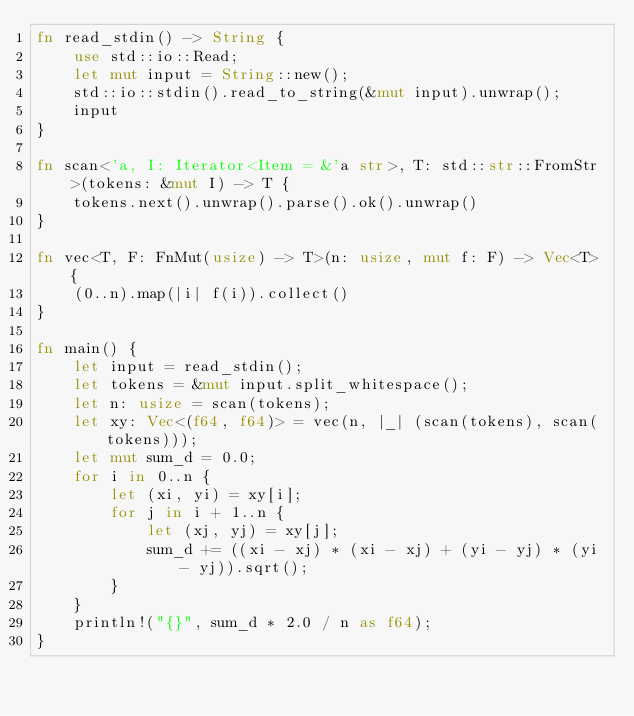Convert code to text. <code><loc_0><loc_0><loc_500><loc_500><_Rust_>fn read_stdin() -> String {
    use std::io::Read;
    let mut input = String::new();
    std::io::stdin().read_to_string(&mut input).unwrap();
    input
}

fn scan<'a, I: Iterator<Item = &'a str>, T: std::str::FromStr>(tokens: &mut I) -> T {
    tokens.next().unwrap().parse().ok().unwrap()
}

fn vec<T, F: FnMut(usize) -> T>(n: usize, mut f: F) -> Vec<T> {
    (0..n).map(|i| f(i)).collect()
}

fn main() {
    let input = read_stdin();
    let tokens = &mut input.split_whitespace();
    let n: usize = scan(tokens);
    let xy: Vec<(f64, f64)> = vec(n, |_| (scan(tokens), scan(tokens)));
    let mut sum_d = 0.0;
    for i in 0..n {
        let (xi, yi) = xy[i];
        for j in i + 1..n {
            let (xj, yj) = xy[j];
            sum_d += ((xi - xj) * (xi - xj) + (yi - yj) * (yi - yj)).sqrt();
        }
    }
    println!("{}", sum_d * 2.0 / n as f64);
}
</code> 